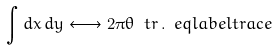Convert formula to latex. <formula><loc_0><loc_0><loc_500><loc_500>\int d x \, d y \longleftrightarrow 2 \pi \theta \ t r \, . \ e q l a b e l { t r a c e }</formula> 